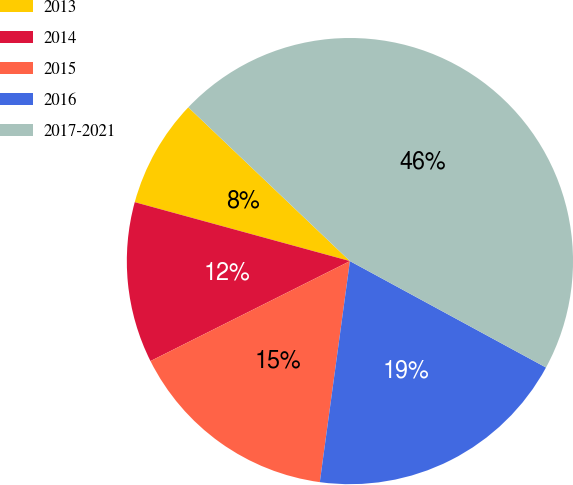<chart> <loc_0><loc_0><loc_500><loc_500><pie_chart><fcel>2013<fcel>2014<fcel>2015<fcel>2016<fcel>2017-2021<nl><fcel>7.85%<fcel>11.65%<fcel>15.45%<fcel>19.24%<fcel>45.81%<nl></chart> 